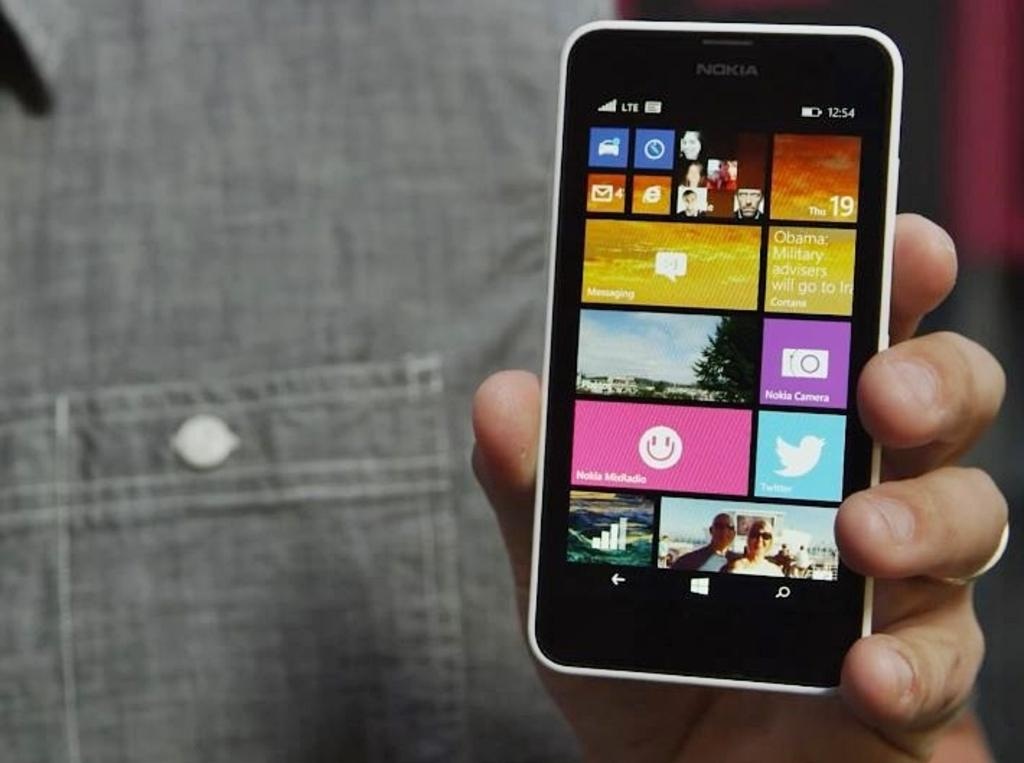Provide a one-sentence caption for the provided image. the front of a nokia phone that shows the nokia midradio app. 